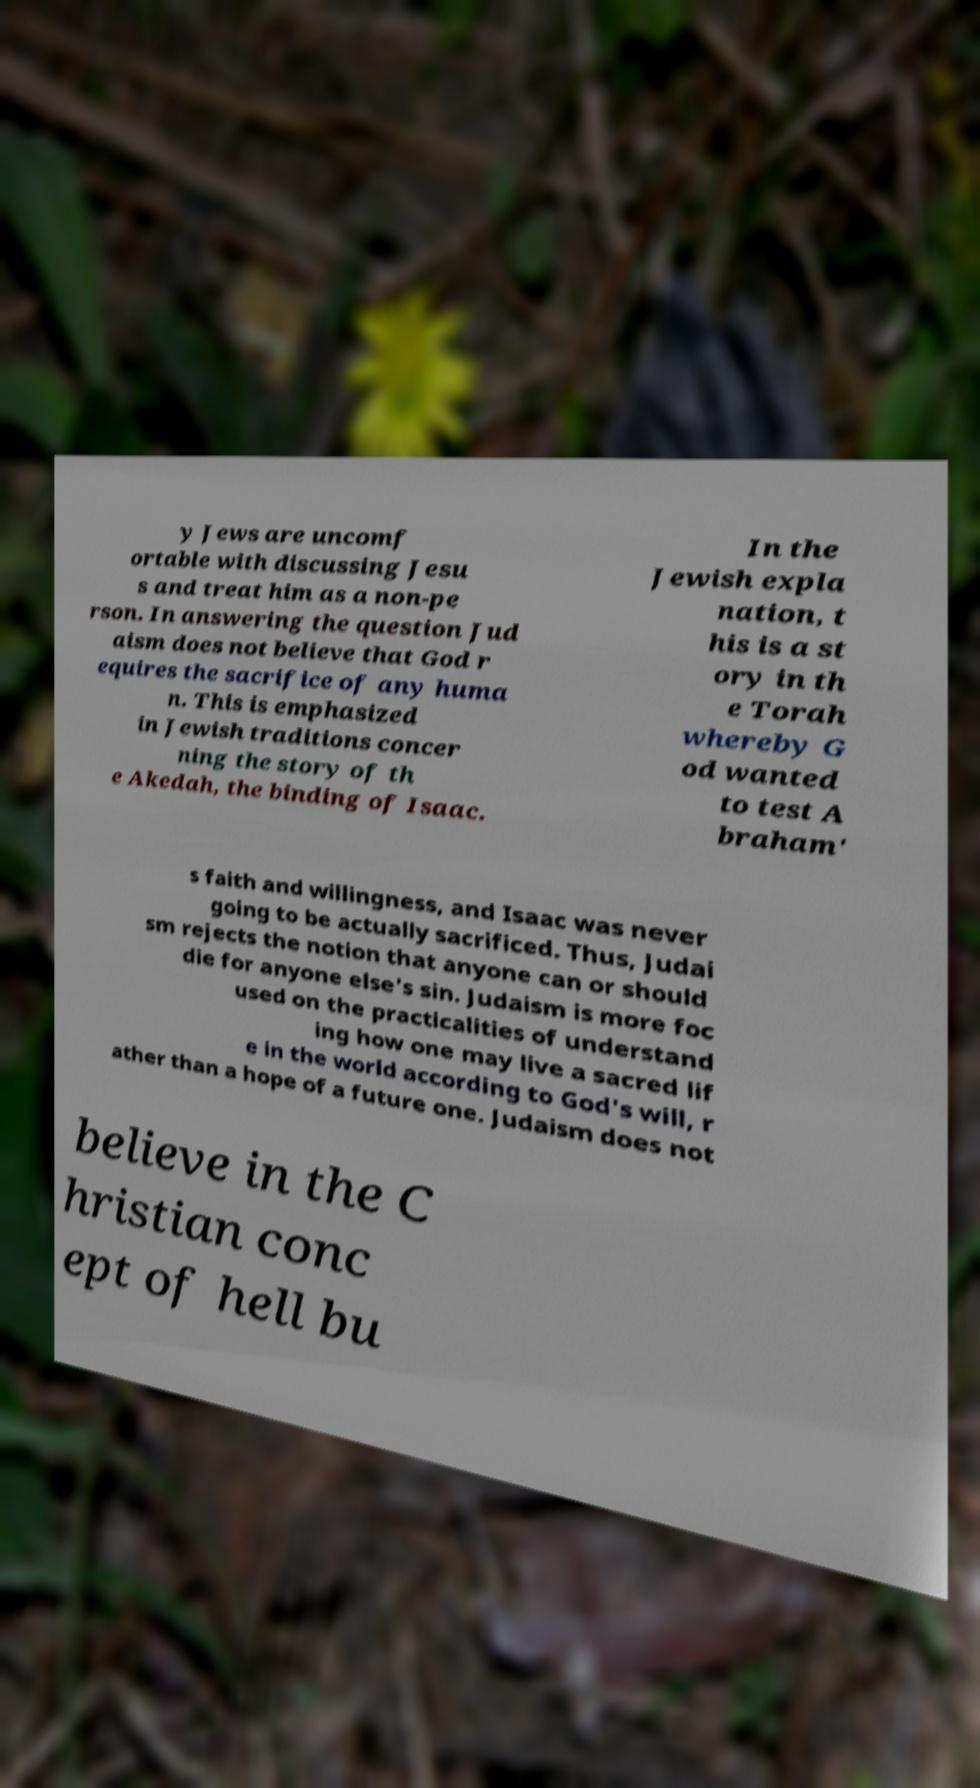What messages or text are displayed in this image? I need them in a readable, typed format. y Jews are uncomf ortable with discussing Jesu s and treat him as a non-pe rson. In answering the question Jud aism does not believe that God r equires the sacrifice of any huma n. This is emphasized in Jewish traditions concer ning the story of th e Akedah, the binding of Isaac. In the Jewish expla nation, t his is a st ory in th e Torah whereby G od wanted to test A braham' s faith and willingness, and Isaac was never going to be actually sacrificed. Thus, Judai sm rejects the notion that anyone can or should die for anyone else's sin. Judaism is more foc used on the practicalities of understand ing how one may live a sacred lif e in the world according to God's will, r ather than a hope of a future one. Judaism does not believe in the C hristian conc ept of hell bu 